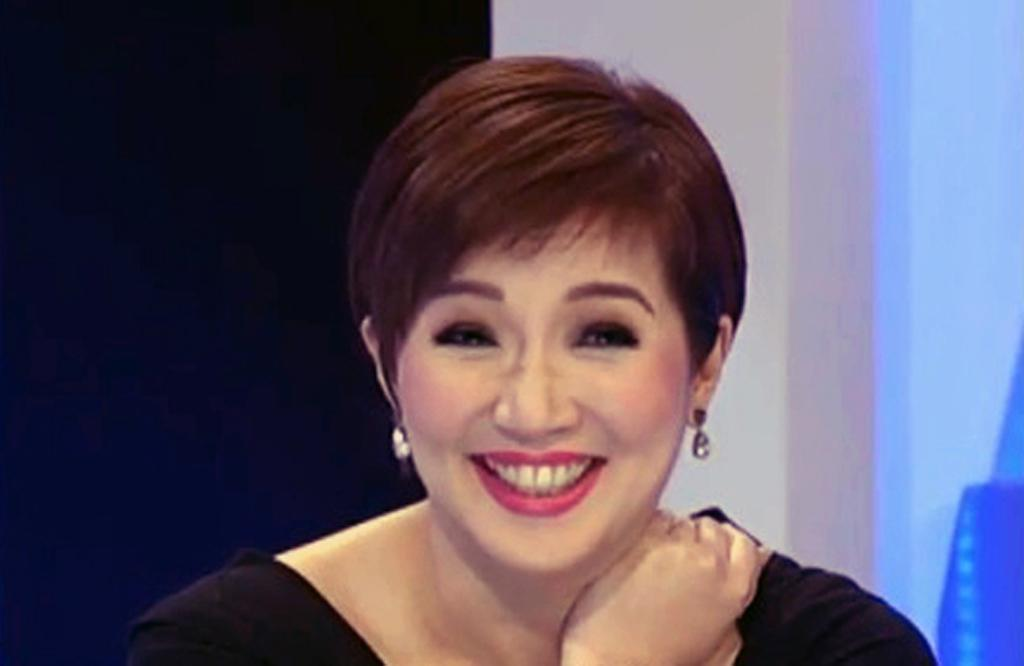Who is the main subject in the image? There is a lady in the center of the image. What is the lady doing in the image? The lady is smiling. What is the lady wearing in the image? The lady is wearing a black dress. What can be seen in the background of the image? There is a wall and a curtain in the background of the image. What is the rate at which the mountain is growing in the image? There is no mountain present in the image, so it is not possible to determine the rate at which it might be growing. 